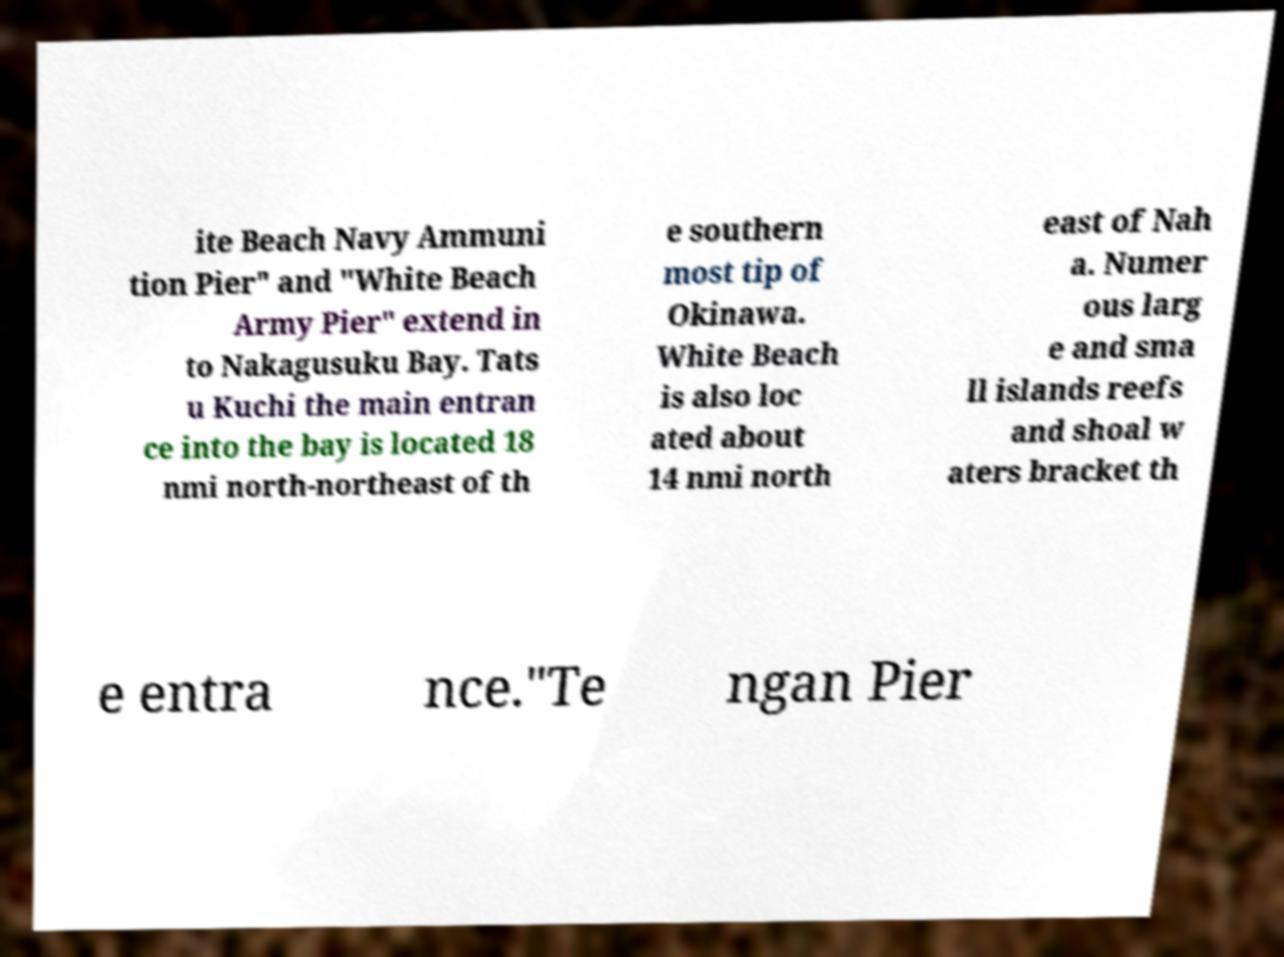Please read and relay the text visible in this image. What does it say? ite Beach Navy Ammuni tion Pier" and "White Beach Army Pier" extend in to Nakagusuku Bay. Tats u Kuchi the main entran ce into the bay is located 18 nmi north-northeast of th e southern most tip of Okinawa. White Beach is also loc ated about 14 nmi north east of Nah a. Numer ous larg e and sma ll islands reefs and shoal w aters bracket th e entra nce."Te ngan Pier 